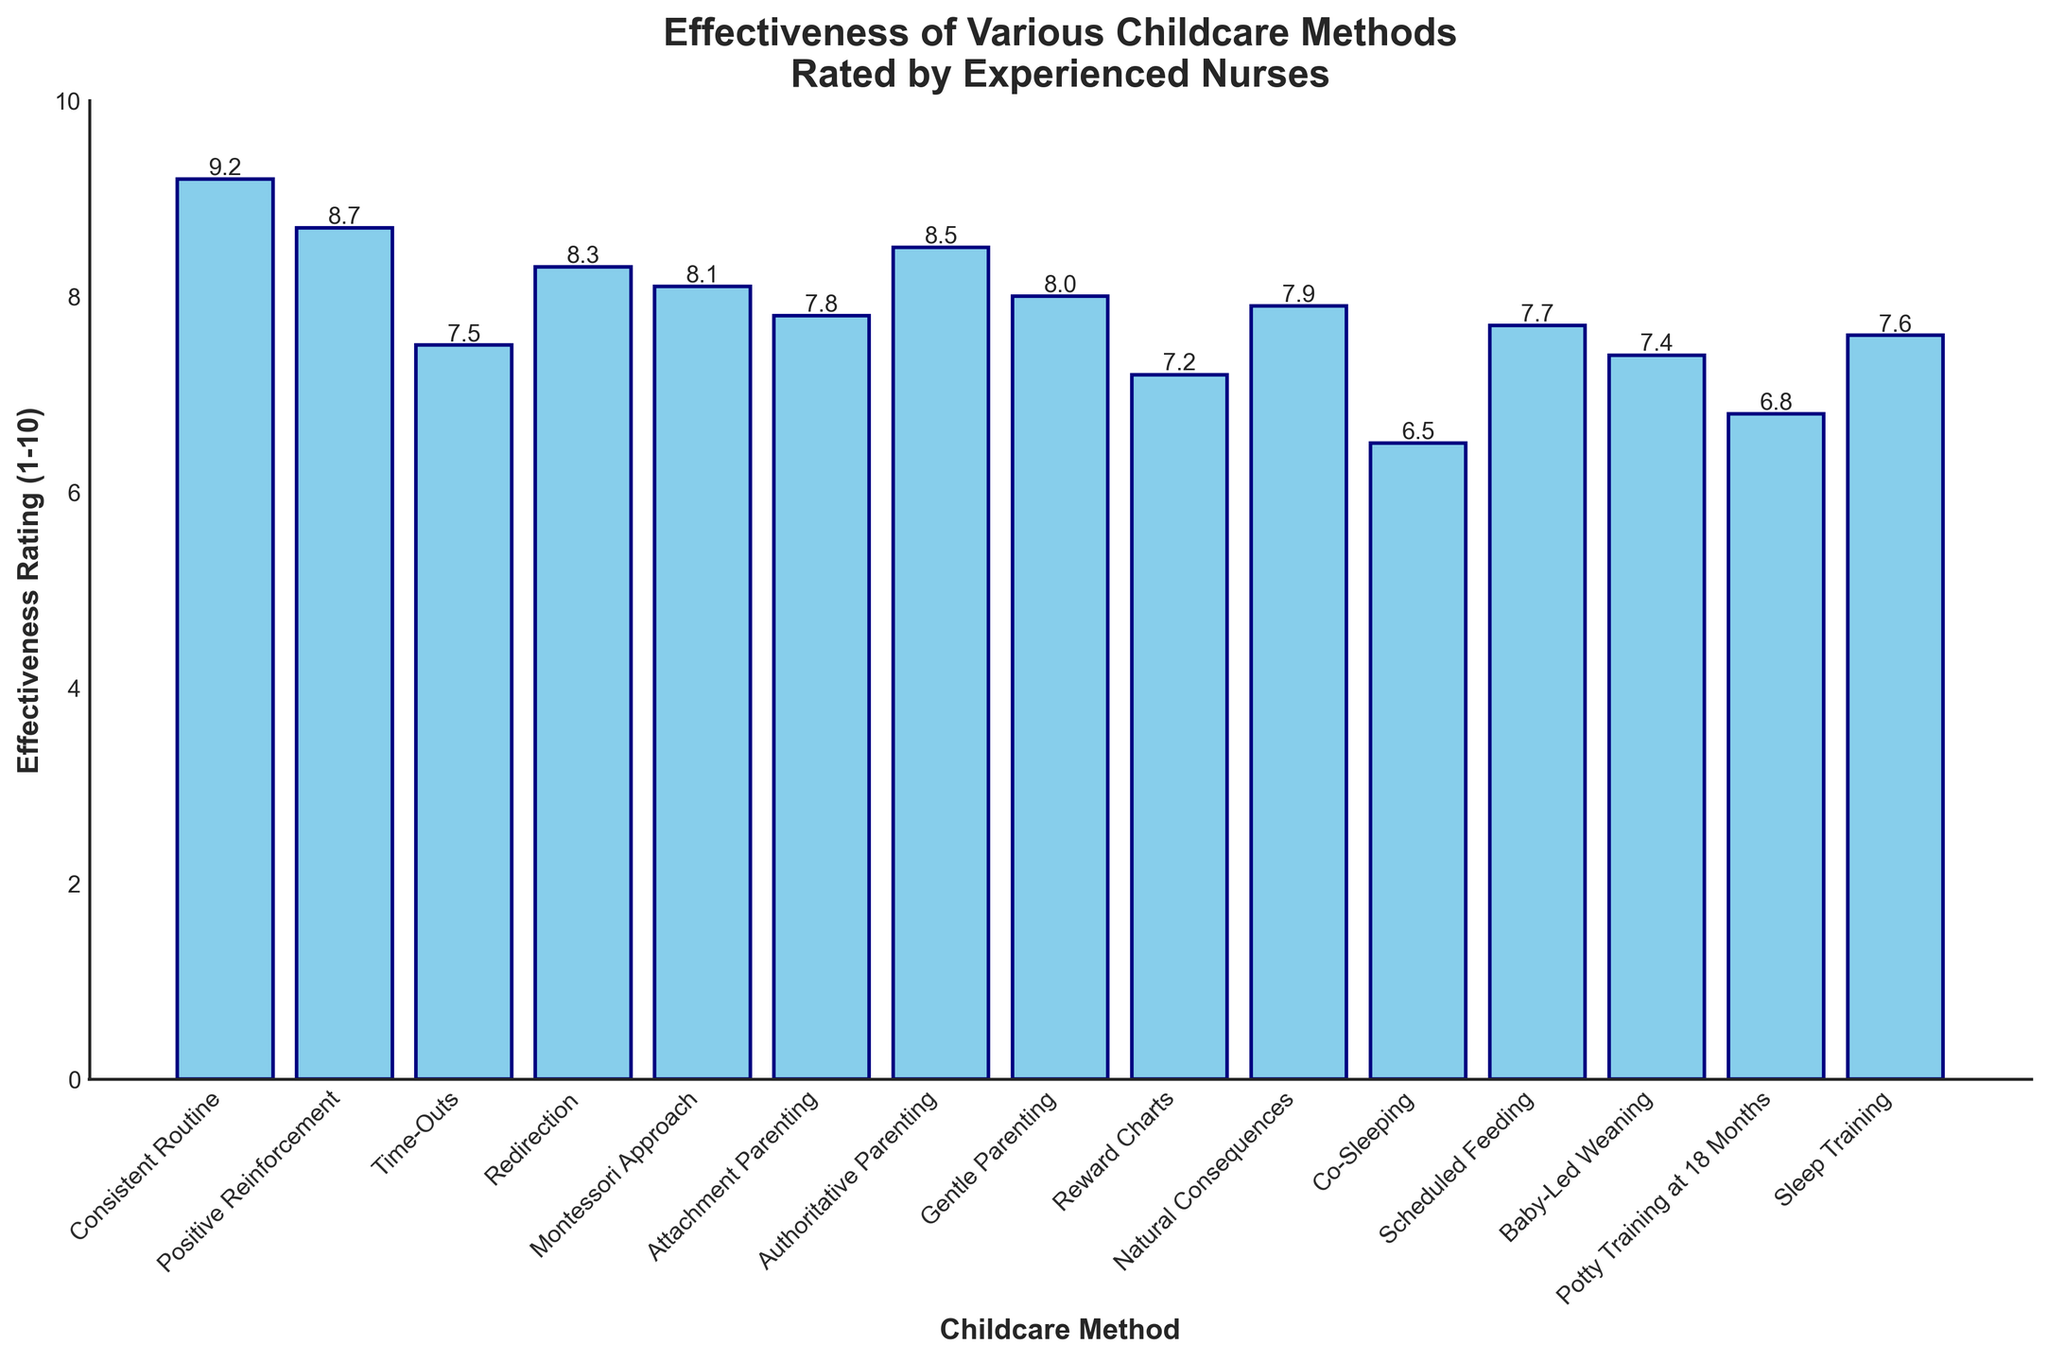What's the highest effectiveness rating among the childcare methods? Look at the bar representing the effectiveness ratings for each method. The highest bar indicates the highest rating.
Answer: 9.2 Which childcare method received the lowest effectiveness rating? Identify the shortest bar in the chart, which corresponds to the lowest rating.
Answer: Co-Sleeping How many methods have an effectiveness rating of 8 or higher? Count the bars that reach or surpass the value of 8 on the vertical axis.
Answer: 8 Which two childcare methods have the closest effectiveness rating? Compare each method's ratings and identify the pairs with the smallest differences. We see that Gentle Parenting (8.0) and Montessori Approach (8.1) are closest.
Answer: Gentle Parenting and Montessori Approach What's the difference in effectiveness rating between the highest-rated and lowest-rated methods? Subtract the effectiveness rating of the lowest-rated method from the highest-rated method: 9.2 (Consistent Routine) - 6.5 (Co-Sleeping) = 2.7
Answer: 2.7 Which childcare method is rated more effective, Redirection or Authoritative Parenting? Compare the heights of the bars for Redirection and Authoritative Parenting. Redirection has an effectiveness rating of 8.3, while Authoritative Parenting has 8.5.
Answer: Authoritative Parenting What's the average effectiveness rating of all the childcare methods? Sum all the effectiveness ratings and divide by the total number of methods: (9.2 + 8.7 + 7.5 + 8.3 + 8.1 + 7.8 + 8.5 + 8.0 + 7.2 + 7.9 + 6.5 + 7.7 + 7.4 + 6.8 + 7.6) / 15 ≈ 7.78
Answer: ~7.78 Does any childcare method have an exact rating of 7.5? Look through the bars to find one that exactly aligns with the value of 7.5 on the vertical axis.
Answer: Time-Outs Which method is rated higher, Scheduled Feeding or Baby-Led Weaning? Compare the effectiveness ratings of Scheduled Feeding (7.7) and Baby-Led Weaning (7.4).
Answer: Scheduled Feeding 